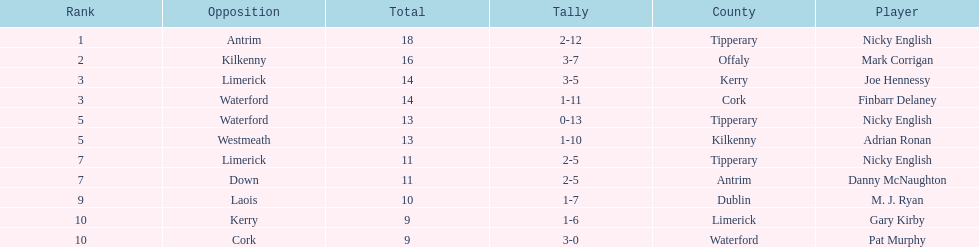Which player has achieved the top ranking? Nicky English. 